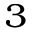<formula> <loc_0><loc_0><loc_500><loc_500>^ { 3 }</formula> 